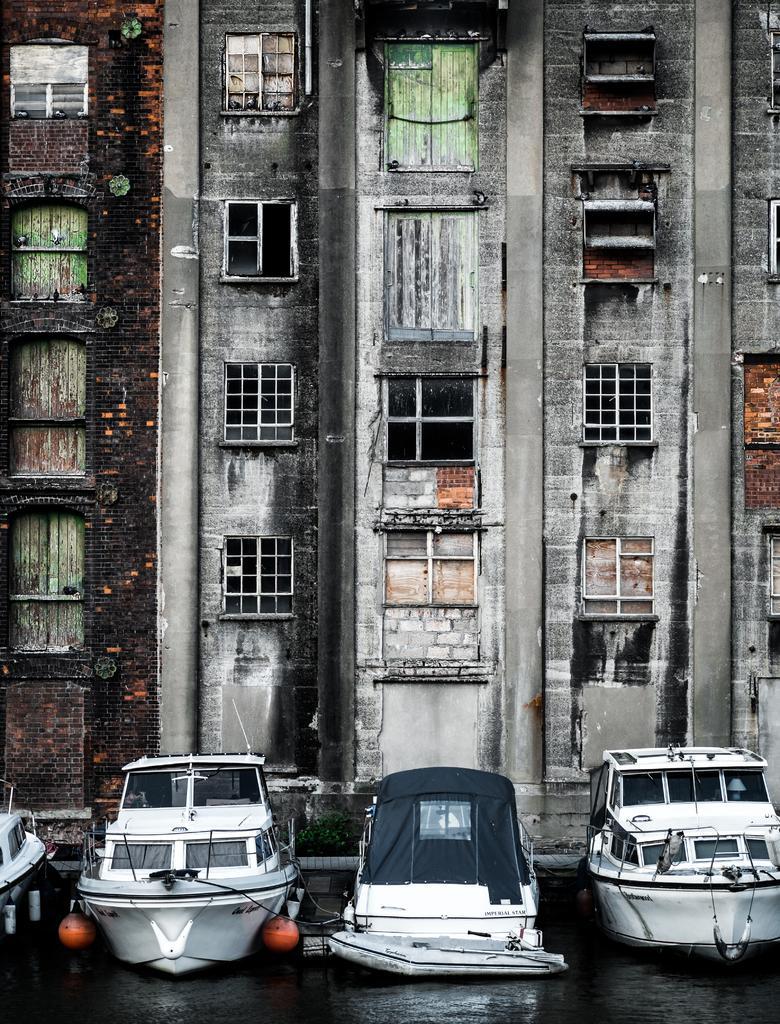Can you describe this image briefly? In this picture we can see water at the bottom, there are four boats in the water, in the background there is a building, we can see windows of the building. 